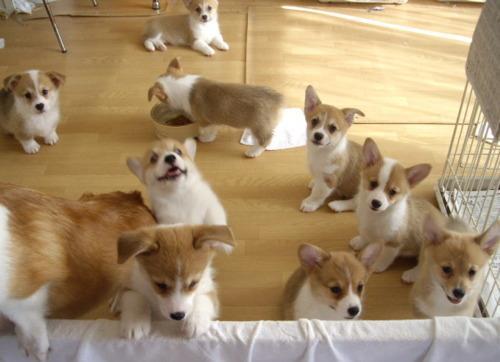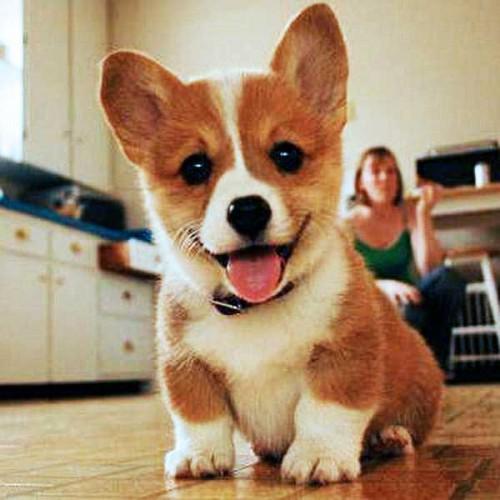The first image is the image on the left, the second image is the image on the right. For the images shown, is this caption "There are more than four dogs." true? Answer yes or no. Yes. The first image is the image on the left, the second image is the image on the right. Analyze the images presented: Is the assertion "At least one hand is touching a dog, and at least one image contains a single dog with upright ears." valid? Answer yes or no. No. 